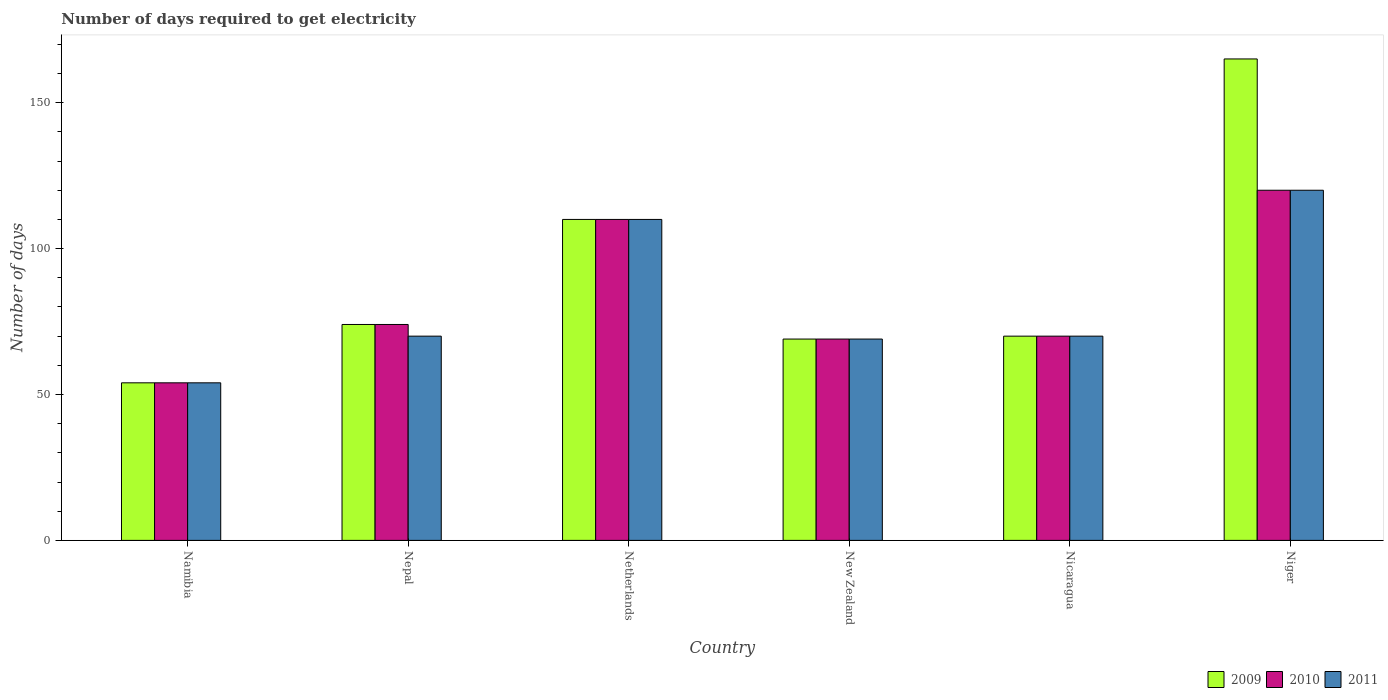Are the number of bars on each tick of the X-axis equal?
Ensure brevity in your answer.  Yes. How many bars are there on the 1st tick from the left?
Keep it short and to the point. 3. How many bars are there on the 5th tick from the right?
Ensure brevity in your answer.  3. What is the label of the 5th group of bars from the left?
Provide a succinct answer. Nicaragua. In how many cases, is the number of bars for a given country not equal to the number of legend labels?
Offer a very short reply. 0. Across all countries, what is the maximum number of days required to get electricity in in 2010?
Give a very brief answer. 120. In which country was the number of days required to get electricity in in 2011 maximum?
Provide a succinct answer. Niger. In which country was the number of days required to get electricity in in 2009 minimum?
Your answer should be very brief. Namibia. What is the total number of days required to get electricity in in 2009 in the graph?
Provide a succinct answer. 542. What is the difference between the number of days required to get electricity in in 2010 in Nepal and that in Niger?
Offer a terse response. -46. What is the difference between the number of days required to get electricity in in 2009 in Nepal and the number of days required to get electricity in in 2010 in Netherlands?
Ensure brevity in your answer.  -36. What is the average number of days required to get electricity in in 2010 per country?
Give a very brief answer. 82.83. What is the difference between the number of days required to get electricity in of/in 2009 and number of days required to get electricity in of/in 2011 in Niger?
Offer a terse response. 45. In how many countries, is the number of days required to get electricity in in 2010 greater than 130 days?
Offer a terse response. 0. What is the ratio of the number of days required to get electricity in in 2009 in Nepal to that in New Zealand?
Offer a very short reply. 1.07. What is the difference between the highest and the second highest number of days required to get electricity in in 2010?
Keep it short and to the point. 46. What is the difference between the highest and the lowest number of days required to get electricity in in 2011?
Your response must be concise. 66. Is the sum of the number of days required to get electricity in in 2009 in Namibia and New Zealand greater than the maximum number of days required to get electricity in in 2011 across all countries?
Ensure brevity in your answer.  Yes. What does the 1st bar from the left in Niger represents?
Make the answer very short. 2009. Is it the case that in every country, the sum of the number of days required to get electricity in in 2011 and number of days required to get electricity in in 2010 is greater than the number of days required to get electricity in in 2009?
Provide a succinct answer. Yes. How many legend labels are there?
Make the answer very short. 3. What is the title of the graph?
Offer a very short reply. Number of days required to get electricity. What is the label or title of the X-axis?
Your answer should be very brief. Country. What is the label or title of the Y-axis?
Ensure brevity in your answer.  Number of days. What is the Number of days of 2009 in Namibia?
Your answer should be compact. 54. What is the Number of days of 2011 in Namibia?
Make the answer very short. 54. What is the Number of days of 2009 in Nepal?
Give a very brief answer. 74. What is the Number of days in 2011 in Nepal?
Make the answer very short. 70. What is the Number of days in 2009 in Netherlands?
Provide a short and direct response. 110. What is the Number of days of 2010 in Netherlands?
Offer a very short reply. 110. What is the Number of days in 2011 in Netherlands?
Offer a very short reply. 110. What is the Number of days of 2010 in New Zealand?
Your response must be concise. 69. What is the Number of days of 2011 in New Zealand?
Keep it short and to the point. 69. What is the Number of days of 2009 in Nicaragua?
Make the answer very short. 70. What is the Number of days of 2011 in Nicaragua?
Provide a short and direct response. 70. What is the Number of days in 2009 in Niger?
Provide a succinct answer. 165. What is the Number of days in 2010 in Niger?
Give a very brief answer. 120. What is the Number of days in 2011 in Niger?
Give a very brief answer. 120. Across all countries, what is the maximum Number of days of 2009?
Ensure brevity in your answer.  165. Across all countries, what is the maximum Number of days of 2010?
Ensure brevity in your answer.  120. Across all countries, what is the maximum Number of days in 2011?
Give a very brief answer. 120. Across all countries, what is the minimum Number of days of 2011?
Your answer should be compact. 54. What is the total Number of days of 2009 in the graph?
Keep it short and to the point. 542. What is the total Number of days in 2010 in the graph?
Provide a short and direct response. 497. What is the total Number of days of 2011 in the graph?
Provide a succinct answer. 493. What is the difference between the Number of days in 2009 in Namibia and that in Netherlands?
Offer a very short reply. -56. What is the difference between the Number of days in 2010 in Namibia and that in Netherlands?
Your answer should be very brief. -56. What is the difference between the Number of days in 2011 in Namibia and that in Netherlands?
Your answer should be very brief. -56. What is the difference between the Number of days in 2010 in Namibia and that in New Zealand?
Your response must be concise. -15. What is the difference between the Number of days in 2011 in Namibia and that in New Zealand?
Your answer should be compact. -15. What is the difference between the Number of days of 2009 in Namibia and that in Nicaragua?
Provide a short and direct response. -16. What is the difference between the Number of days in 2010 in Namibia and that in Nicaragua?
Ensure brevity in your answer.  -16. What is the difference between the Number of days of 2009 in Namibia and that in Niger?
Ensure brevity in your answer.  -111. What is the difference between the Number of days in 2010 in Namibia and that in Niger?
Your response must be concise. -66. What is the difference between the Number of days in 2011 in Namibia and that in Niger?
Ensure brevity in your answer.  -66. What is the difference between the Number of days in 2009 in Nepal and that in Netherlands?
Provide a short and direct response. -36. What is the difference between the Number of days in 2010 in Nepal and that in Netherlands?
Your answer should be compact. -36. What is the difference between the Number of days of 2009 in Nepal and that in New Zealand?
Provide a short and direct response. 5. What is the difference between the Number of days in 2010 in Nepal and that in New Zealand?
Make the answer very short. 5. What is the difference between the Number of days in 2011 in Nepal and that in New Zealand?
Provide a short and direct response. 1. What is the difference between the Number of days in 2009 in Nepal and that in Nicaragua?
Keep it short and to the point. 4. What is the difference between the Number of days in 2010 in Nepal and that in Nicaragua?
Your response must be concise. 4. What is the difference between the Number of days of 2009 in Nepal and that in Niger?
Your answer should be very brief. -91. What is the difference between the Number of days of 2010 in Nepal and that in Niger?
Your answer should be compact. -46. What is the difference between the Number of days in 2011 in Nepal and that in Niger?
Make the answer very short. -50. What is the difference between the Number of days in 2009 in Netherlands and that in New Zealand?
Your response must be concise. 41. What is the difference between the Number of days in 2010 in Netherlands and that in New Zealand?
Ensure brevity in your answer.  41. What is the difference between the Number of days in 2011 in Netherlands and that in New Zealand?
Provide a short and direct response. 41. What is the difference between the Number of days in 2010 in Netherlands and that in Nicaragua?
Provide a short and direct response. 40. What is the difference between the Number of days of 2009 in Netherlands and that in Niger?
Make the answer very short. -55. What is the difference between the Number of days of 2010 in Netherlands and that in Niger?
Provide a short and direct response. -10. What is the difference between the Number of days of 2009 in New Zealand and that in Nicaragua?
Keep it short and to the point. -1. What is the difference between the Number of days in 2009 in New Zealand and that in Niger?
Your response must be concise. -96. What is the difference between the Number of days in 2010 in New Zealand and that in Niger?
Your answer should be very brief. -51. What is the difference between the Number of days in 2011 in New Zealand and that in Niger?
Your answer should be compact. -51. What is the difference between the Number of days in 2009 in Nicaragua and that in Niger?
Your answer should be compact. -95. What is the difference between the Number of days of 2011 in Nicaragua and that in Niger?
Offer a very short reply. -50. What is the difference between the Number of days of 2009 in Namibia and the Number of days of 2010 in Nepal?
Offer a very short reply. -20. What is the difference between the Number of days of 2010 in Namibia and the Number of days of 2011 in Nepal?
Provide a succinct answer. -16. What is the difference between the Number of days in 2009 in Namibia and the Number of days in 2010 in Netherlands?
Keep it short and to the point. -56. What is the difference between the Number of days of 2009 in Namibia and the Number of days of 2011 in Netherlands?
Offer a very short reply. -56. What is the difference between the Number of days in 2010 in Namibia and the Number of days in 2011 in Netherlands?
Offer a terse response. -56. What is the difference between the Number of days of 2010 in Namibia and the Number of days of 2011 in New Zealand?
Your answer should be compact. -15. What is the difference between the Number of days of 2010 in Namibia and the Number of days of 2011 in Nicaragua?
Offer a terse response. -16. What is the difference between the Number of days in 2009 in Namibia and the Number of days in 2010 in Niger?
Keep it short and to the point. -66. What is the difference between the Number of days of 2009 in Namibia and the Number of days of 2011 in Niger?
Provide a succinct answer. -66. What is the difference between the Number of days in 2010 in Namibia and the Number of days in 2011 in Niger?
Offer a very short reply. -66. What is the difference between the Number of days of 2009 in Nepal and the Number of days of 2010 in Netherlands?
Ensure brevity in your answer.  -36. What is the difference between the Number of days in 2009 in Nepal and the Number of days in 2011 in Netherlands?
Ensure brevity in your answer.  -36. What is the difference between the Number of days in 2010 in Nepal and the Number of days in 2011 in Netherlands?
Offer a very short reply. -36. What is the difference between the Number of days in 2009 in Nepal and the Number of days in 2010 in New Zealand?
Provide a short and direct response. 5. What is the difference between the Number of days of 2010 in Nepal and the Number of days of 2011 in New Zealand?
Offer a very short reply. 5. What is the difference between the Number of days of 2009 in Nepal and the Number of days of 2010 in Nicaragua?
Provide a succinct answer. 4. What is the difference between the Number of days of 2009 in Nepal and the Number of days of 2010 in Niger?
Your answer should be compact. -46. What is the difference between the Number of days of 2009 in Nepal and the Number of days of 2011 in Niger?
Provide a short and direct response. -46. What is the difference between the Number of days of 2010 in Nepal and the Number of days of 2011 in Niger?
Your response must be concise. -46. What is the difference between the Number of days of 2009 in Netherlands and the Number of days of 2010 in New Zealand?
Your response must be concise. 41. What is the difference between the Number of days of 2009 in Netherlands and the Number of days of 2011 in New Zealand?
Offer a terse response. 41. What is the difference between the Number of days of 2010 in Netherlands and the Number of days of 2011 in New Zealand?
Provide a short and direct response. 41. What is the difference between the Number of days in 2010 in Netherlands and the Number of days in 2011 in Nicaragua?
Your answer should be very brief. 40. What is the difference between the Number of days in 2009 in Netherlands and the Number of days in 2010 in Niger?
Provide a succinct answer. -10. What is the difference between the Number of days of 2009 in New Zealand and the Number of days of 2011 in Nicaragua?
Provide a succinct answer. -1. What is the difference between the Number of days of 2010 in New Zealand and the Number of days of 2011 in Nicaragua?
Ensure brevity in your answer.  -1. What is the difference between the Number of days in 2009 in New Zealand and the Number of days in 2010 in Niger?
Give a very brief answer. -51. What is the difference between the Number of days of 2009 in New Zealand and the Number of days of 2011 in Niger?
Ensure brevity in your answer.  -51. What is the difference between the Number of days of 2010 in New Zealand and the Number of days of 2011 in Niger?
Offer a terse response. -51. What is the difference between the Number of days in 2009 in Nicaragua and the Number of days in 2010 in Niger?
Provide a short and direct response. -50. What is the difference between the Number of days in 2010 in Nicaragua and the Number of days in 2011 in Niger?
Your answer should be very brief. -50. What is the average Number of days in 2009 per country?
Your answer should be compact. 90.33. What is the average Number of days of 2010 per country?
Your answer should be very brief. 82.83. What is the average Number of days of 2011 per country?
Offer a terse response. 82.17. What is the difference between the Number of days of 2009 and Number of days of 2010 in Namibia?
Your answer should be very brief. 0. What is the difference between the Number of days of 2009 and Number of days of 2010 in Nepal?
Your answer should be very brief. 0. What is the difference between the Number of days in 2009 and Number of days in 2011 in Nepal?
Ensure brevity in your answer.  4. What is the difference between the Number of days of 2010 and Number of days of 2011 in Nepal?
Provide a succinct answer. 4. What is the difference between the Number of days in 2009 and Number of days in 2010 in Netherlands?
Make the answer very short. 0. What is the difference between the Number of days in 2009 and Number of days in 2011 in Netherlands?
Provide a succinct answer. 0. What is the difference between the Number of days of 2010 and Number of days of 2011 in Netherlands?
Give a very brief answer. 0. What is the difference between the Number of days of 2010 and Number of days of 2011 in New Zealand?
Offer a very short reply. 0. What is the difference between the Number of days of 2009 and Number of days of 2010 in Nicaragua?
Offer a terse response. 0. What is the difference between the Number of days of 2009 and Number of days of 2011 in Nicaragua?
Give a very brief answer. 0. What is the difference between the Number of days of 2009 and Number of days of 2011 in Niger?
Give a very brief answer. 45. What is the difference between the Number of days in 2010 and Number of days in 2011 in Niger?
Your answer should be very brief. 0. What is the ratio of the Number of days in 2009 in Namibia to that in Nepal?
Offer a very short reply. 0.73. What is the ratio of the Number of days in 2010 in Namibia to that in Nepal?
Keep it short and to the point. 0.73. What is the ratio of the Number of days in 2011 in Namibia to that in Nepal?
Offer a very short reply. 0.77. What is the ratio of the Number of days in 2009 in Namibia to that in Netherlands?
Make the answer very short. 0.49. What is the ratio of the Number of days of 2010 in Namibia to that in Netherlands?
Offer a very short reply. 0.49. What is the ratio of the Number of days of 2011 in Namibia to that in Netherlands?
Offer a terse response. 0.49. What is the ratio of the Number of days in 2009 in Namibia to that in New Zealand?
Provide a short and direct response. 0.78. What is the ratio of the Number of days of 2010 in Namibia to that in New Zealand?
Give a very brief answer. 0.78. What is the ratio of the Number of days of 2011 in Namibia to that in New Zealand?
Your answer should be very brief. 0.78. What is the ratio of the Number of days of 2009 in Namibia to that in Nicaragua?
Offer a very short reply. 0.77. What is the ratio of the Number of days in 2010 in Namibia to that in Nicaragua?
Your answer should be very brief. 0.77. What is the ratio of the Number of days in 2011 in Namibia to that in Nicaragua?
Provide a short and direct response. 0.77. What is the ratio of the Number of days of 2009 in Namibia to that in Niger?
Your response must be concise. 0.33. What is the ratio of the Number of days in 2010 in Namibia to that in Niger?
Offer a very short reply. 0.45. What is the ratio of the Number of days of 2011 in Namibia to that in Niger?
Give a very brief answer. 0.45. What is the ratio of the Number of days in 2009 in Nepal to that in Netherlands?
Keep it short and to the point. 0.67. What is the ratio of the Number of days in 2010 in Nepal to that in Netherlands?
Your answer should be compact. 0.67. What is the ratio of the Number of days of 2011 in Nepal to that in Netherlands?
Offer a terse response. 0.64. What is the ratio of the Number of days in 2009 in Nepal to that in New Zealand?
Make the answer very short. 1.07. What is the ratio of the Number of days in 2010 in Nepal to that in New Zealand?
Ensure brevity in your answer.  1.07. What is the ratio of the Number of days of 2011 in Nepal to that in New Zealand?
Offer a very short reply. 1.01. What is the ratio of the Number of days in 2009 in Nepal to that in Nicaragua?
Your answer should be very brief. 1.06. What is the ratio of the Number of days of 2010 in Nepal to that in Nicaragua?
Offer a terse response. 1.06. What is the ratio of the Number of days of 2011 in Nepal to that in Nicaragua?
Keep it short and to the point. 1. What is the ratio of the Number of days of 2009 in Nepal to that in Niger?
Your response must be concise. 0.45. What is the ratio of the Number of days of 2010 in Nepal to that in Niger?
Offer a terse response. 0.62. What is the ratio of the Number of days in 2011 in Nepal to that in Niger?
Offer a very short reply. 0.58. What is the ratio of the Number of days in 2009 in Netherlands to that in New Zealand?
Your answer should be very brief. 1.59. What is the ratio of the Number of days of 2010 in Netherlands to that in New Zealand?
Provide a short and direct response. 1.59. What is the ratio of the Number of days in 2011 in Netherlands to that in New Zealand?
Your answer should be very brief. 1.59. What is the ratio of the Number of days in 2009 in Netherlands to that in Nicaragua?
Give a very brief answer. 1.57. What is the ratio of the Number of days of 2010 in Netherlands to that in Nicaragua?
Provide a short and direct response. 1.57. What is the ratio of the Number of days in 2011 in Netherlands to that in Nicaragua?
Offer a terse response. 1.57. What is the ratio of the Number of days of 2009 in Netherlands to that in Niger?
Provide a succinct answer. 0.67. What is the ratio of the Number of days of 2010 in Netherlands to that in Niger?
Keep it short and to the point. 0.92. What is the ratio of the Number of days of 2011 in Netherlands to that in Niger?
Your answer should be very brief. 0.92. What is the ratio of the Number of days in 2009 in New Zealand to that in Nicaragua?
Give a very brief answer. 0.99. What is the ratio of the Number of days of 2010 in New Zealand to that in Nicaragua?
Your response must be concise. 0.99. What is the ratio of the Number of days in 2011 in New Zealand to that in Nicaragua?
Provide a short and direct response. 0.99. What is the ratio of the Number of days in 2009 in New Zealand to that in Niger?
Your answer should be compact. 0.42. What is the ratio of the Number of days of 2010 in New Zealand to that in Niger?
Your response must be concise. 0.57. What is the ratio of the Number of days of 2011 in New Zealand to that in Niger?
Provide a short and direct response. 0.57. What is the ratio of the Number of days in 2009 in Nicaragua to that in Niger?
Your response must be concise. 0.42. What is the ratio of the Number of days of 2010 in Nicaragua to that in Niger?
Your response must be concise. 0.58. What is the ratio of the Number of days in 2011 in Nicaragua to that in Niger?
Offer a terse response. 0.58. What is the difference between the highest and the second highest Number of days of 2010?
Ensure brevity in your answer.  10. What is the difference between the highest and the lowest Number of days of 2009?
Make the answer very short. 111. What is the difference between the highest and the lowest Number of days of 2011?
Provide a short and direct response. 66. 